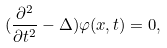<formula> <loc_0><loc_0><loc_500><loc_500>( \frac { \partial ^ { 2 } } { \partial t ^ { 2 } } - \Delta ) \varphi ( x , t ) = 0 ,</formula> 